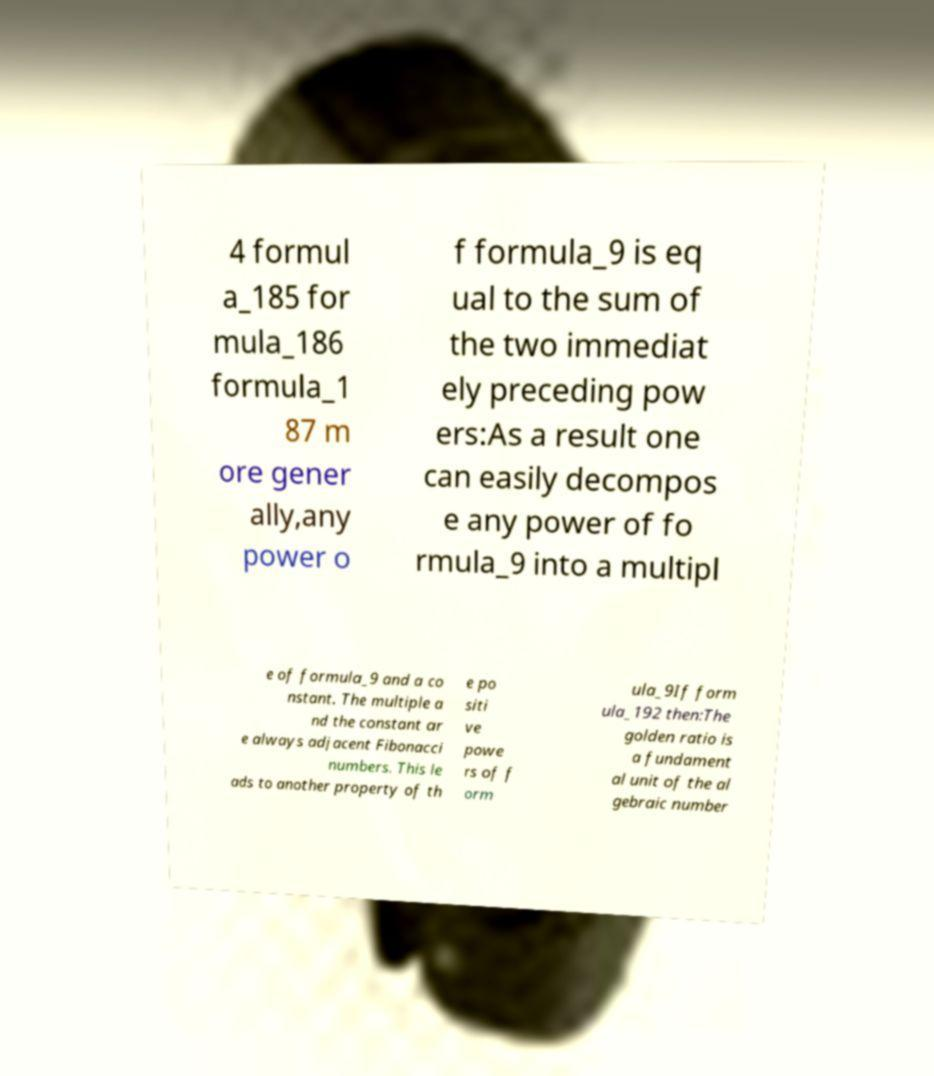Could you extract and type out the text from this image? 4 formul a_185 for mula_186 formula_1 87 m ore gener ally,any power o f formula_9 is eq ual to the sum of the two immediat ely preceding pow ers:As a result one can easily decompos e any power of fo rmula_9 into a multipl e of formula_9 and a co nstant. The multiple a nd the constant ar e always adjacent Fibonacci numbers. This le ads to another property of th e po siti ve powe rs of f orm ula_9If form ula_192 then:The golden ratio is a fundament al unit of the al gebraic number 